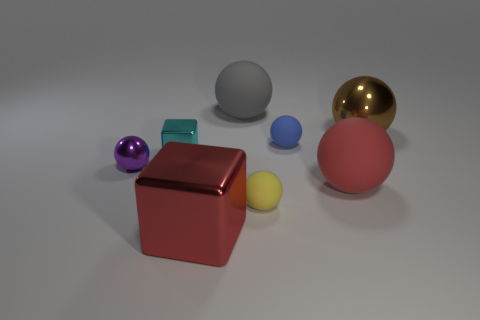Subtract all large brown metal balls. How many balls are left? 5 Subtract all gray spheres. How many spheres are left? 5 Add 2 big green matte blocks. How many objects exist? 10 Subtract all spheres. How many objects are left? 2 Subtract all blue balls. Subtract all green blocks. How many balls are left? 5 Subtract 0 cyan cylinders. How many objects are left? 8 Subtract all metal cubes. Subtract all big cubes. How many objects are left? 5 Add 8 small cyan objects. How many small cyan objects are left? 9 Add 1 brown blocks. How many brown blocks exist? 1 